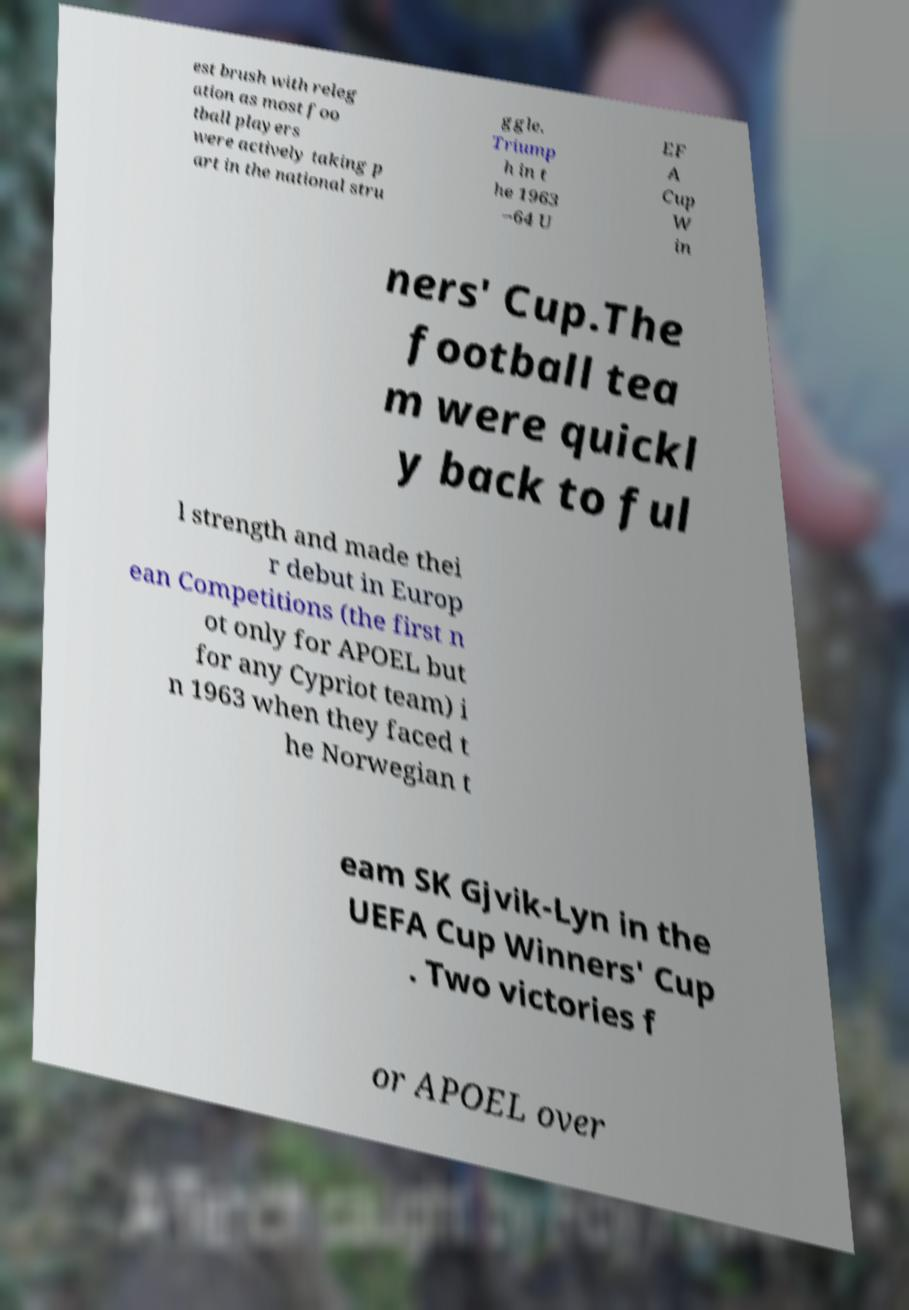There's text embedded in this image that I need extracted. Can you transcribe it verbatim? est brush with releg ation as most foo tball players were actively taking p art in the national stru ggle. Triump h in t he 1963 –64 U EF A Cup W in ners' Cup.The football tea m were quickl y back to ful l strength and made thei r debut in Europ ean Competitions (the first n ot only for APOEL but for any Cypriot team) i n 1963 when they faced t he Norwegian t eam SK Gjvik-Lyn in the UEFA Cup Winners' Cup . Two victories f or APOEL over 